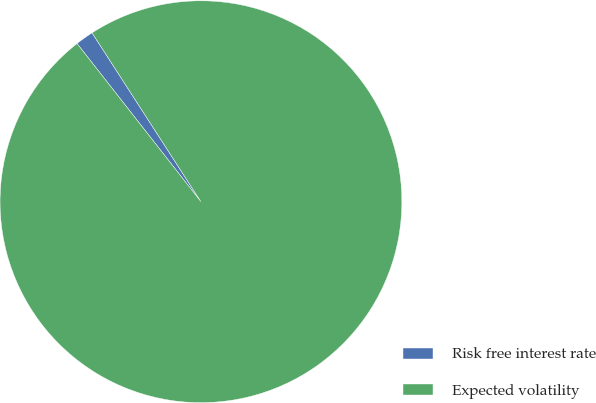Convert chart. <chart><loc_0><loc_0><loc_500><loc_500><pie_chart><fcel>Risk free interest rate<fcel>Expected volatility<nl><fcel>1.46%<fcel>98.54%<nl></chart> 